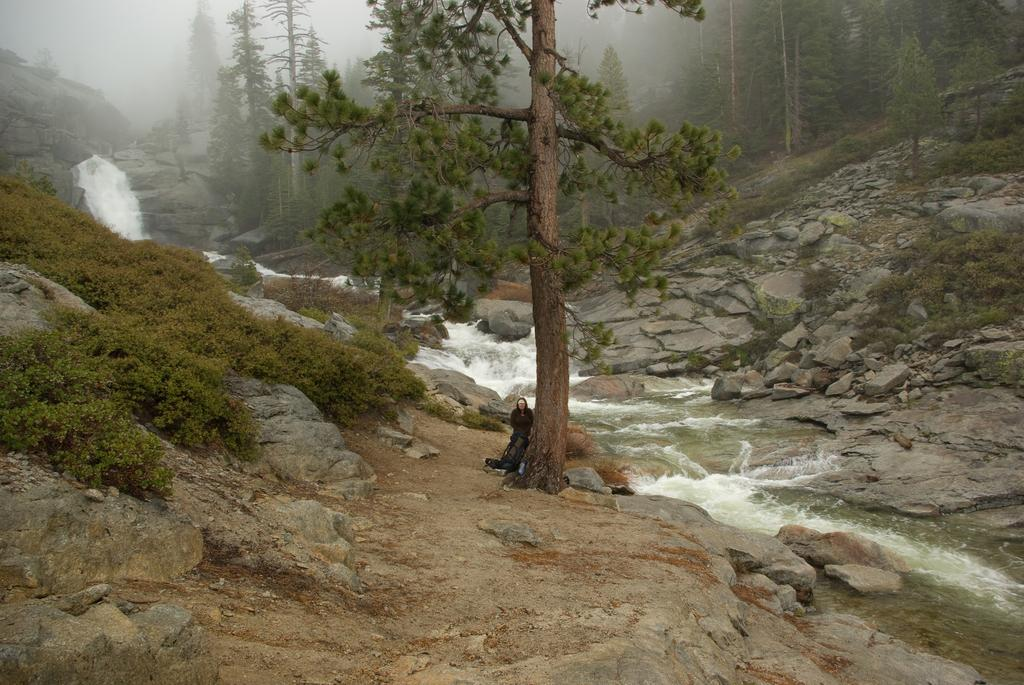What type of geographical feature is visible in the image? There are mountains in the image. What is flowing through the mountains? A river is flowing through the mountains. What type of vegetation is present in the image? There are trees in the center of the image. Can you describe the person's location in the image? A person is standing behind a tree. What type of bit is the person using to transport the cloth in the image? There is no bit or cloth present in the image, and no transportation is depicted. 